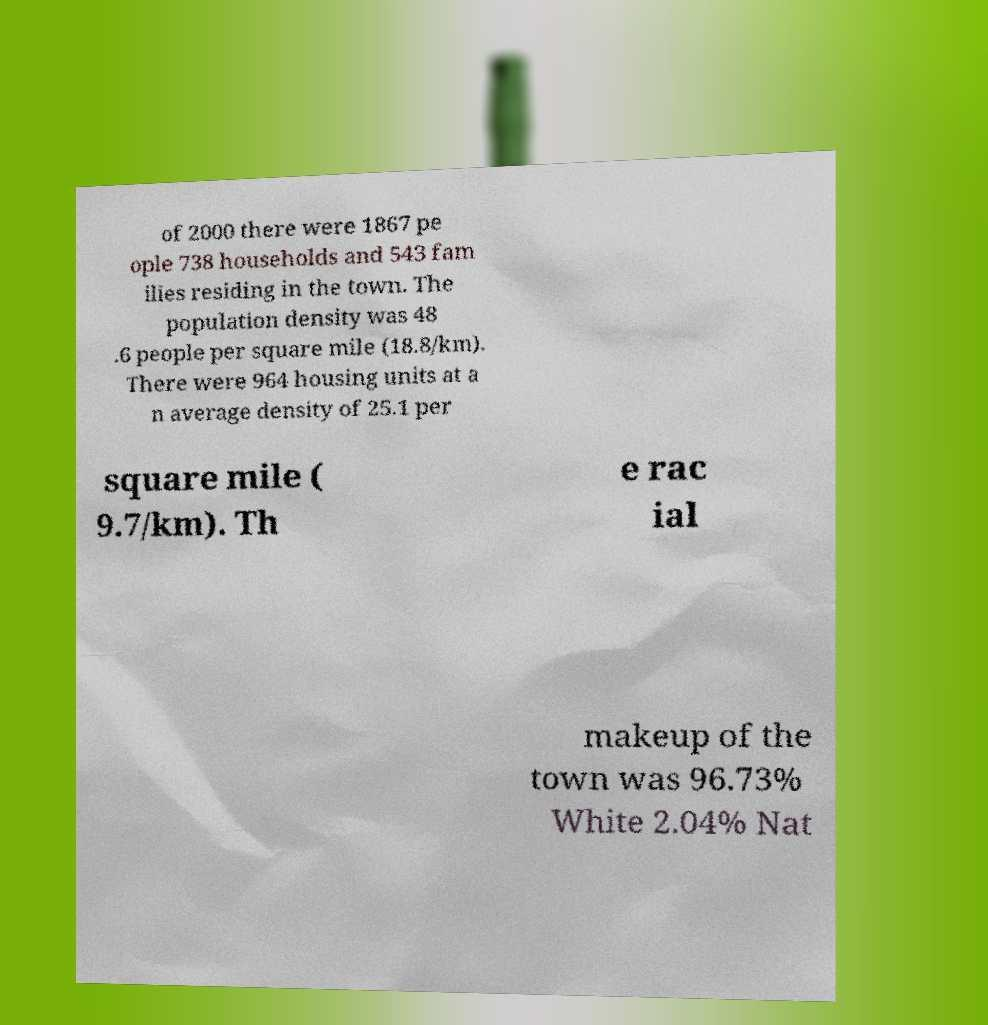Please identify and transcribe the text found in this image. of 2000 there were 1867 pe ople 738 households and 543 fam ilies residing in the town. The population density was 48 .6 people per square mile (18.8/km). There were 964 housing units at a n average density of 25.1 per square mile ( 9.7/km). Th e rac ial makeup of the town was 96.73% White 2.04% Nat 